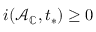Convert formula to latex. <formula><loc_0><loc_0><loc_500><loc_500>i ( \mathcal { A } _ { \mathbb { C } } , t _ { * } ) \geq 0</formula> 